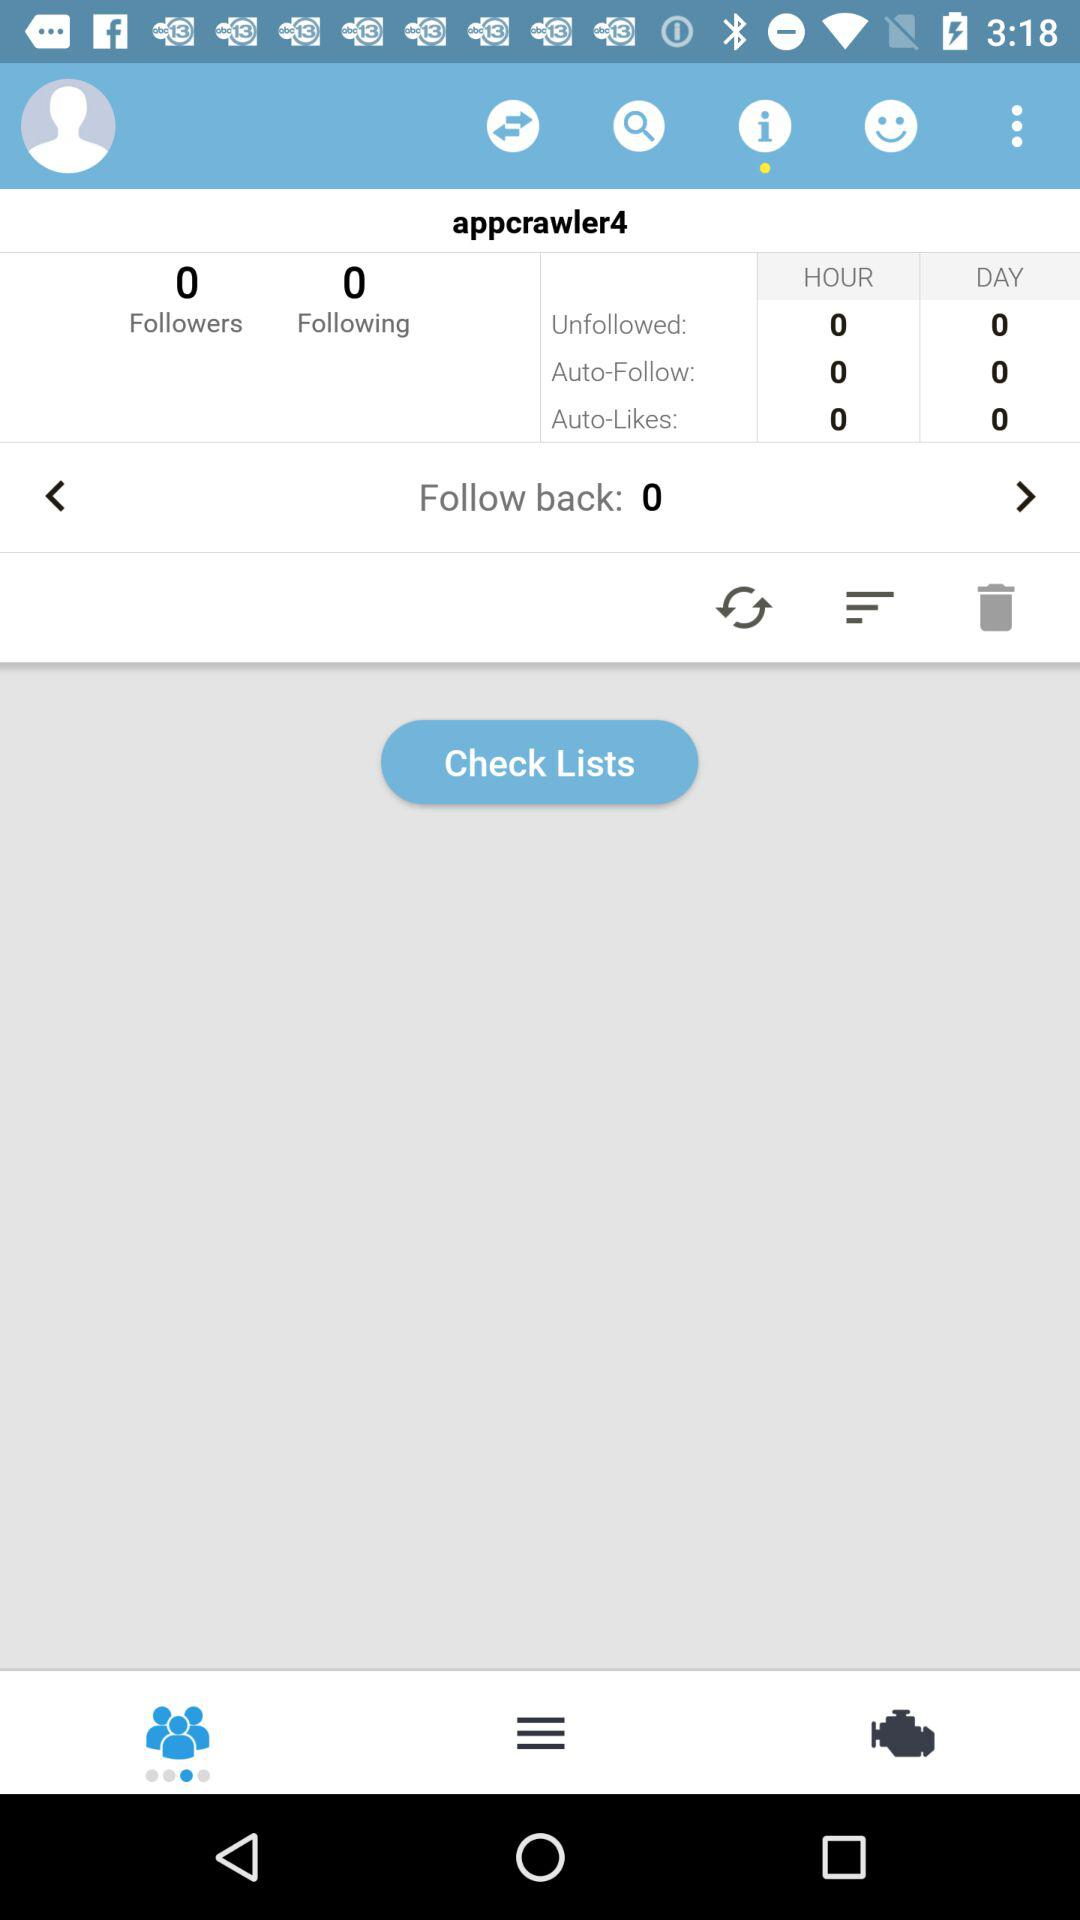What is the username? The username is "appcrawler4". 